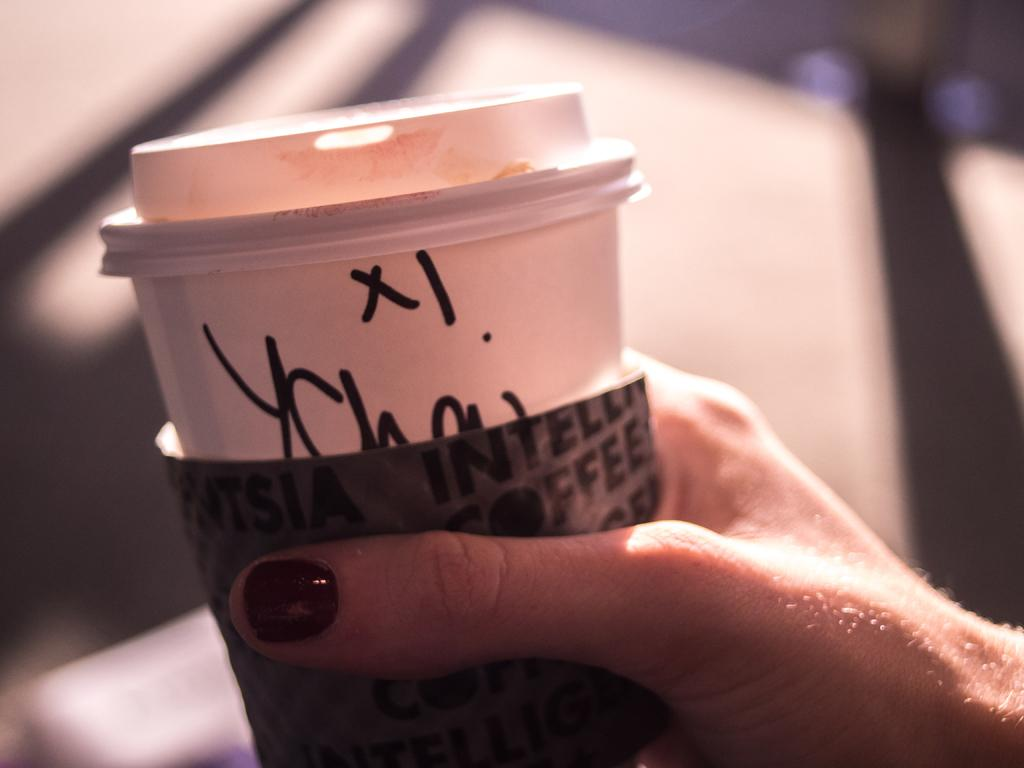What can be seen in the image related to a person's hand? There is a person's hand in the image. What is the hand holding? The hand is holding a white glass. Can you describe the appearance of the thumb nail? The thumb nail has brown color paint on it. What type of vest is the person wearing in the image? There is no vest visible in the image; only a person's hand holding a white glass is shown. 